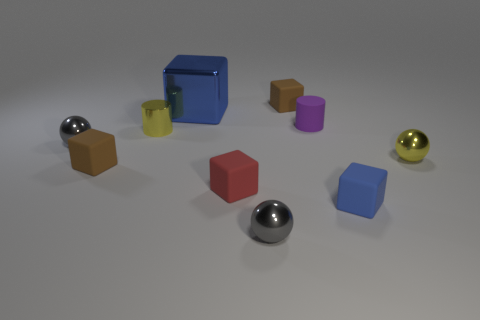How many things are blocks right of the small purple matte thing or shiny things that are on the right side of the blue metallic cube?
Keep it short and to the point. 3. There is a blue cube that is the same size as the purple rubber thing; what is it made of?
Offer a very short reply. Rubber. The big metallic cube has what color?
Ensure brevity in your answer.  Blue. What is the tiny object that is on the right side of the small matte cylinder and behind the blue matte object made of?
Keep it short and to the point. Metal. There is a small block that is behind the purple thing that is behind the red matte thing; is there a tiny cylinder that is to the right of it?
Your answer should be very brief. Yes. There is another block that is the same color as the shiny cube; what size is it?
Ensure brevity in your answer.  Small. Are there any tiny balls left of the big object?
Your response must be concise. Yes. How many other things are the same shape as the large blue thing?
Offer a very short reply. 4. There is a cylinder that is the same size as the purple thing; what is its color?
Provide a succinct answer. Yellow. Is the number of red matte cubes that are in front of the red thing less than the number of matte blocks to the left of the tiny blue cube?
Give a very brief answer. Yes. 